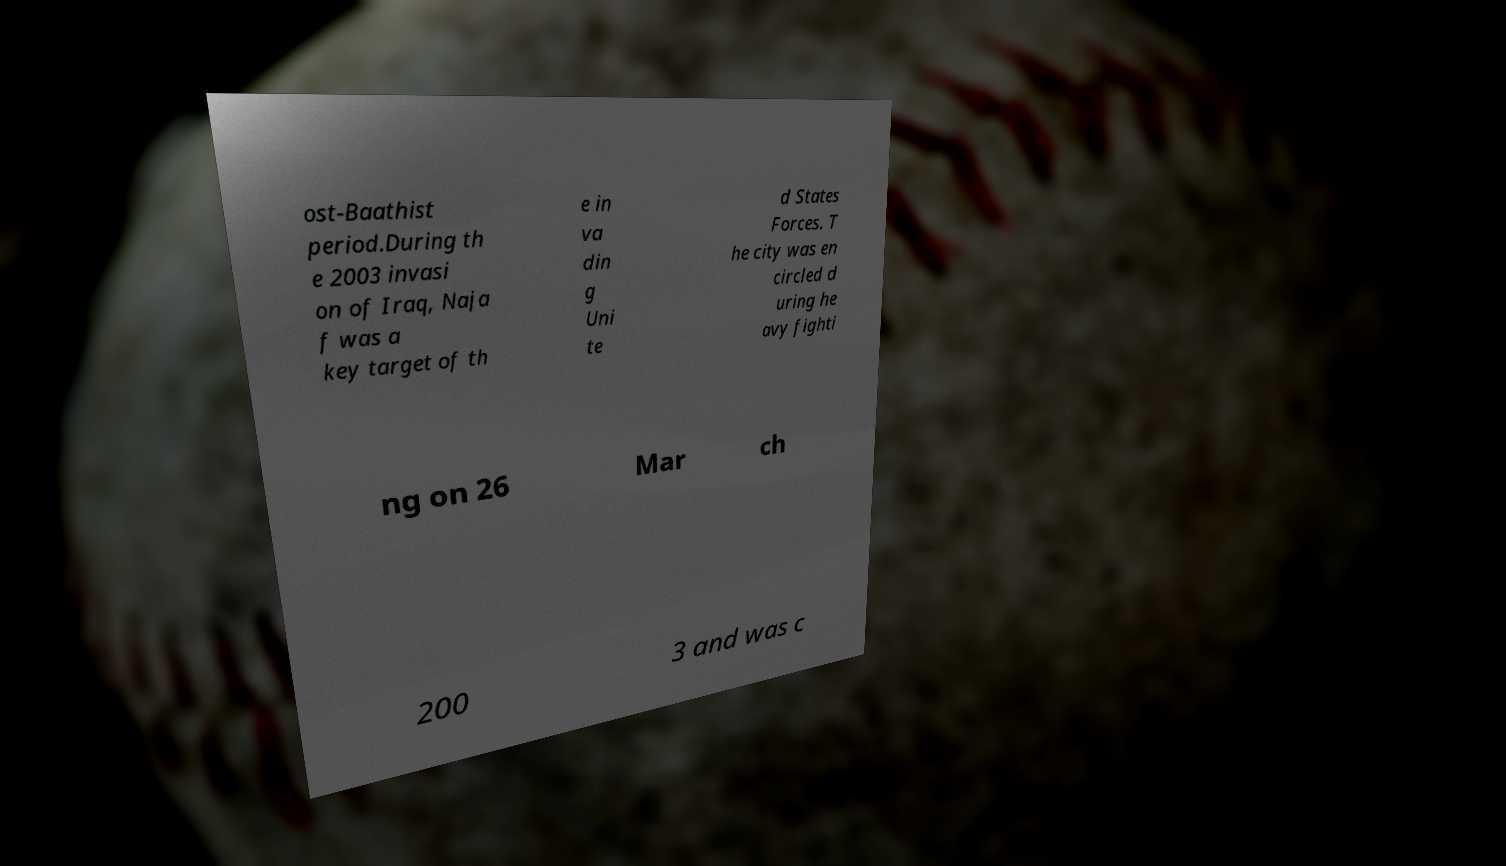Please read and relay the text visible in this image. What does it say? ost-Baathist period.During th e 2003 invasi on of Iraq, Naja f was a key target of th e in va din g Uni te d States Forces. T he city was en circled d uring he avy fighti ng on 26 Mar ch 200 3 and was c 